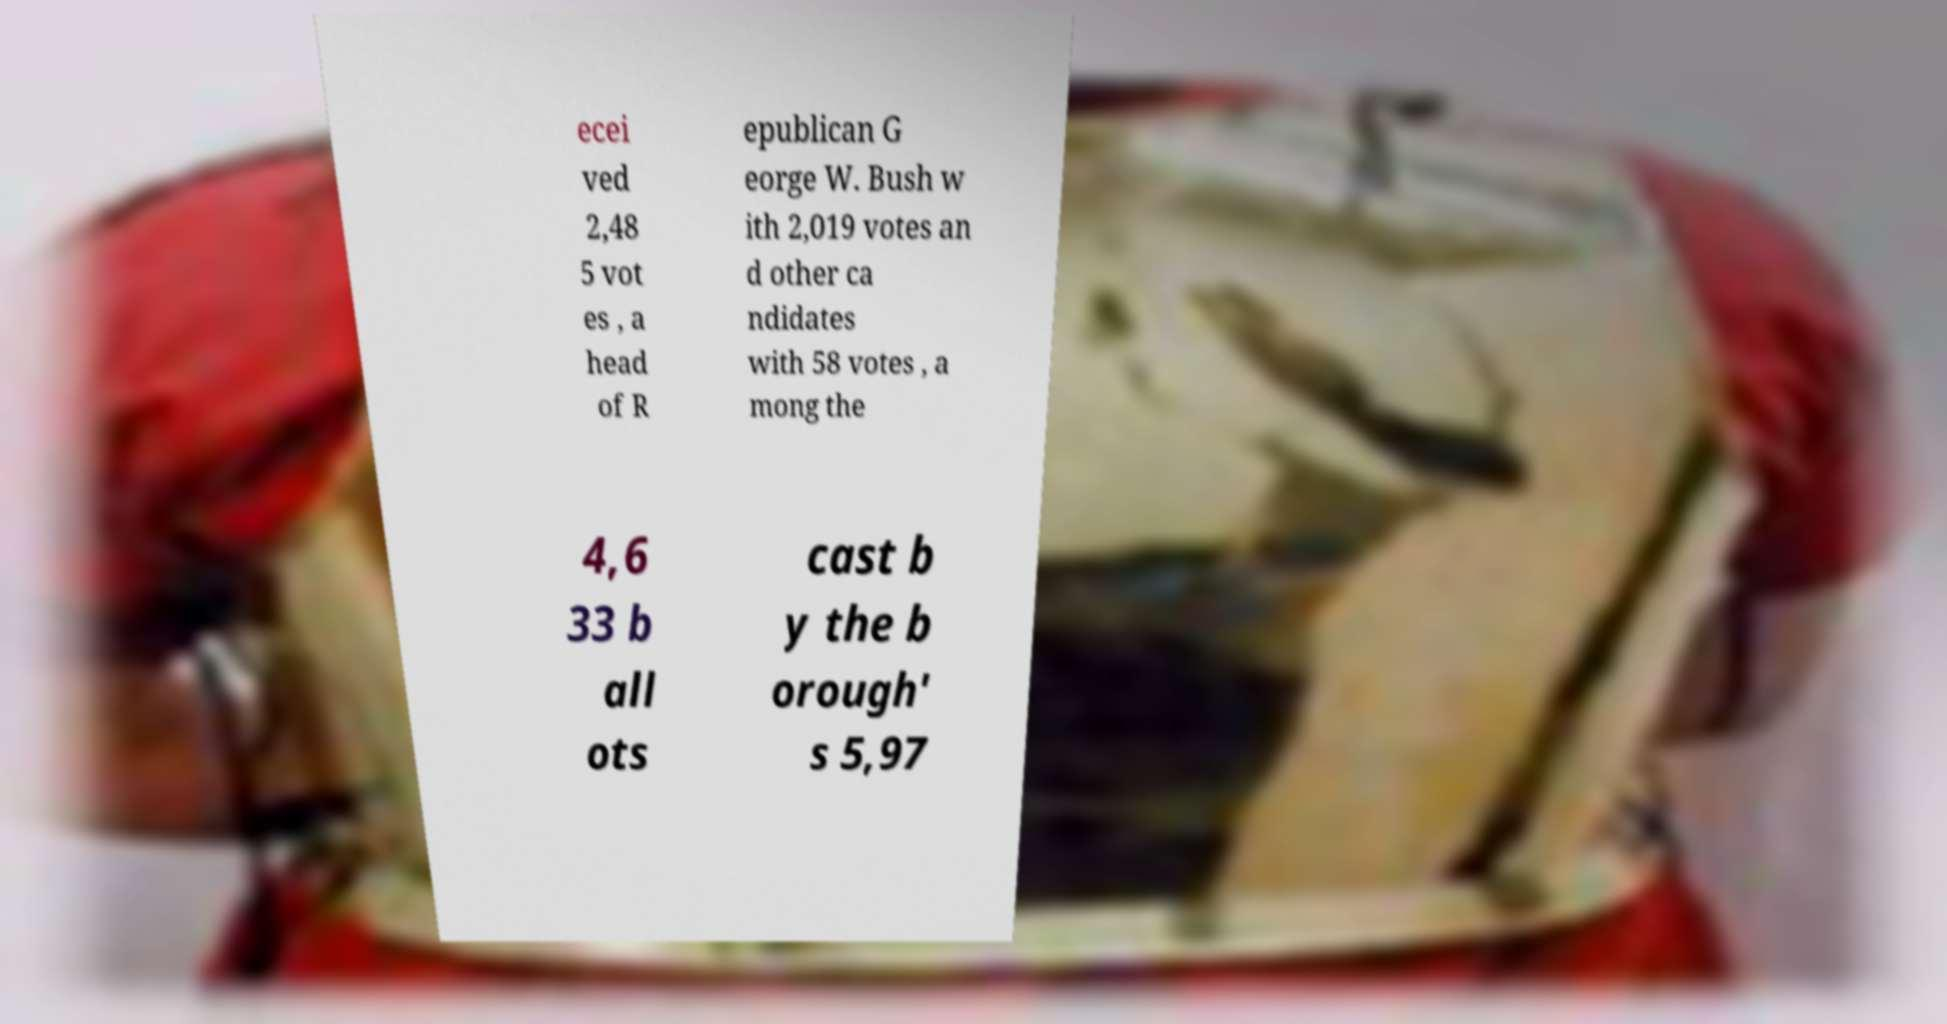Can you read and provide the text displayed in the image?This photo seems to have some interesting text. Can you extract and type it out for me? ecei ved 2,48 5 vot es , a head of R epublican G eorge W. Bush w ith 2,019 votes an d other ca ndidates with 58 votes , a mong the 4,6 33 b all ots cast b y the b orough' s 5,97 